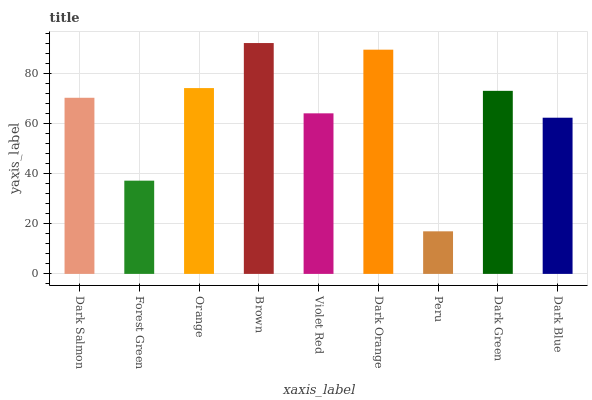Is Brown the maximum?
Answer yes or no. Yes. Is Forest Green the minimum?
Answer yes or no. No. Is Forest Green the maximum?
Answer yes or no. No. Is Dark Salmon greater than Forest Green?
Answer yes or no. Yes. Is Forest Green less than Dark Salmon?
Answer yes or no. Yes. Is Forest Green greater than Dark Salmon?
Answer yes or no. No. Is Dark Salmon less than Forest Green?
Answer yes or no. No. Is Dark Salmon the high median?
Answer yes or no. Yes. Is Dark Salmon the low median?
Answer yes or no. Yes. Is Dark Orange the high median?
Answer yes or no. No. Is Orange the low median?
Answer yes or no. No. 